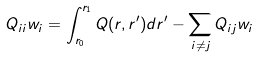Convert formula to latex. <formula><loc_0><loc_0><loc_500><loc_500>Q _ { i i } w _ { i } = \int _ { r _ { 0 } } ^ { r _ { 1 } } Q ( r , r ^ { \prime } ) d r ^ { \prime } - \sum _ { i \neq j } Q _ { i j } w _ { i }</formula> 